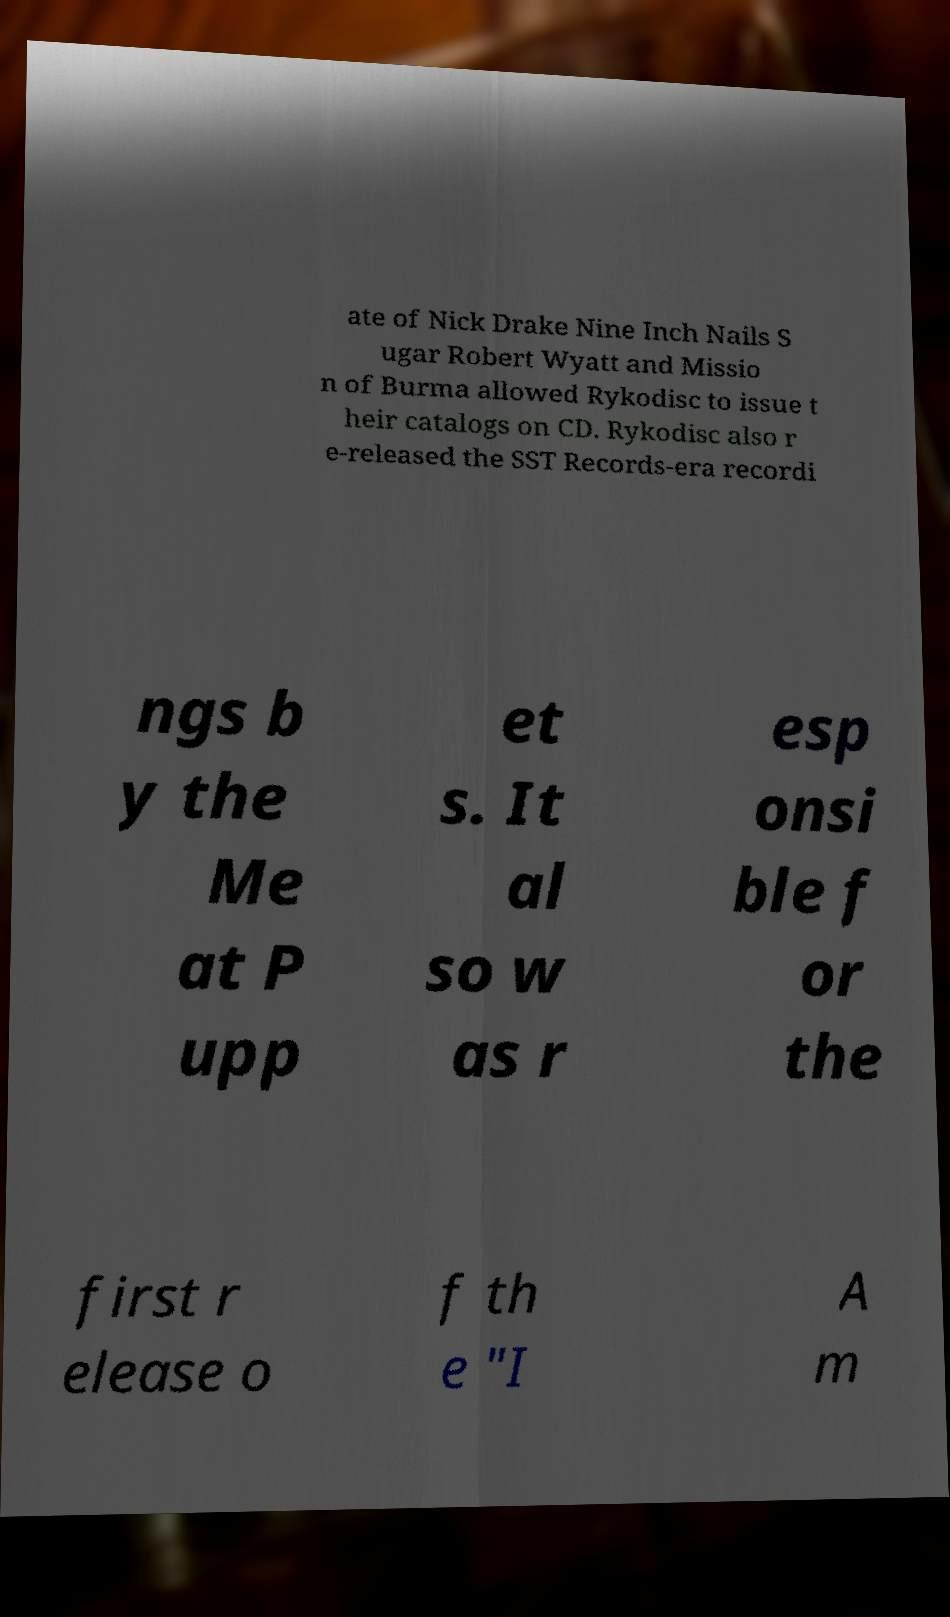Could you assist in decoding the text presented in this image and type it out clearly? ate of Nick Drake Nine Inch Nails S ugar Robert Wyatt and Missio n of Burma allowed Rykodisc to issue t heir catalogs on CD. Rykodisc also r e-released the SST Records-era recordi ngs b y the Me at P upp et s. It al so w as r esp onsi ble f or the first r elease o f th e "I A m 